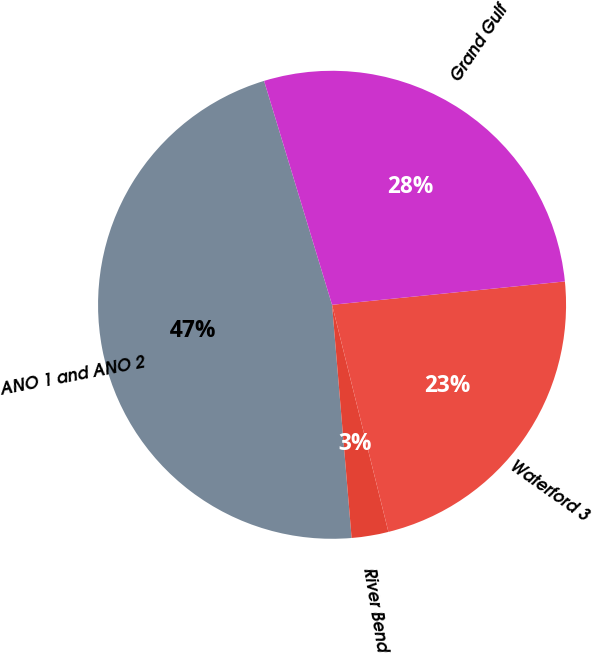Convert chart. <chart><loc_0><loc_0><loc_500><loc_500><pie_chart><fcel>ANO 1 and ANO 2<fcel>River Bend<fcel>Waterford 3<fcel>Grand Gulf<nl><fcel>46.64%<fcel>2.54%<fcel>22.72%<fcel>28.1%<nl></chart> 